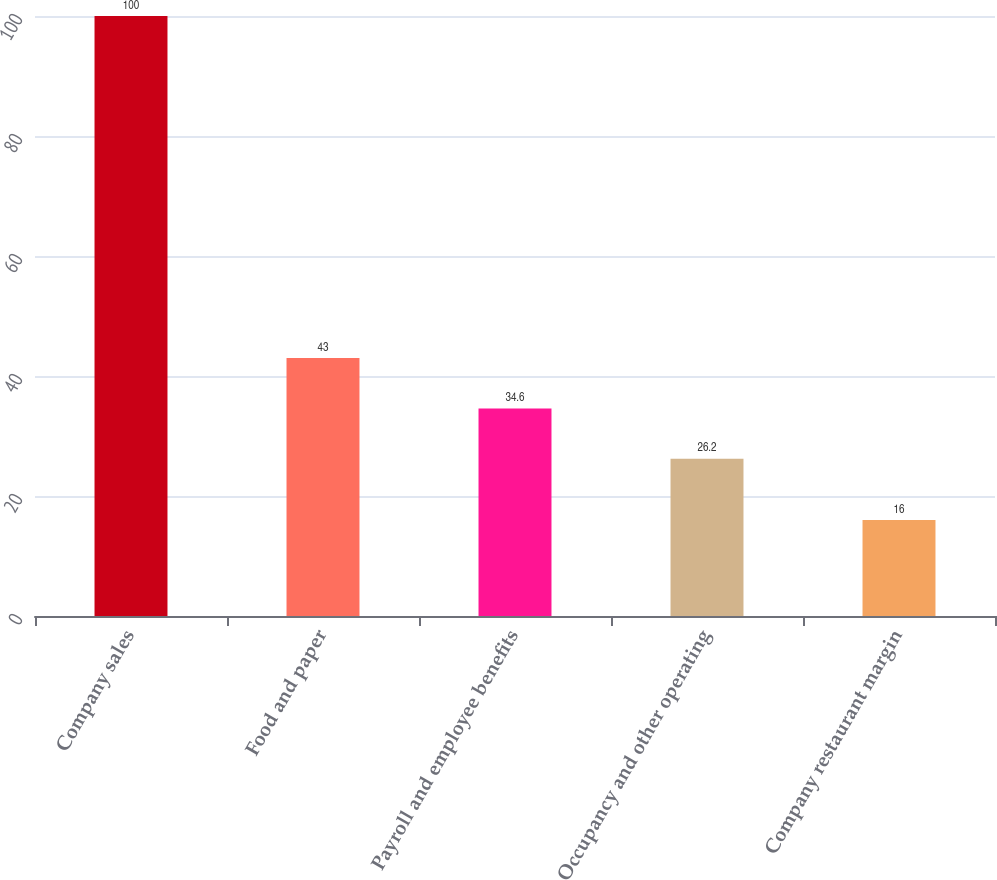<chart> <loc_0><loc_0><loc_500><loc_500><bar_chart><fcel>Company sales<fcel>Food and paper<fcel>Payroll and employee benefits<fcel>Occupancy and other operating<fcel>Company restaurant margin<nl><fcel>100<fcel>43<fcel>34.6<fcel>26.2<fcel>16<nl></chart> 